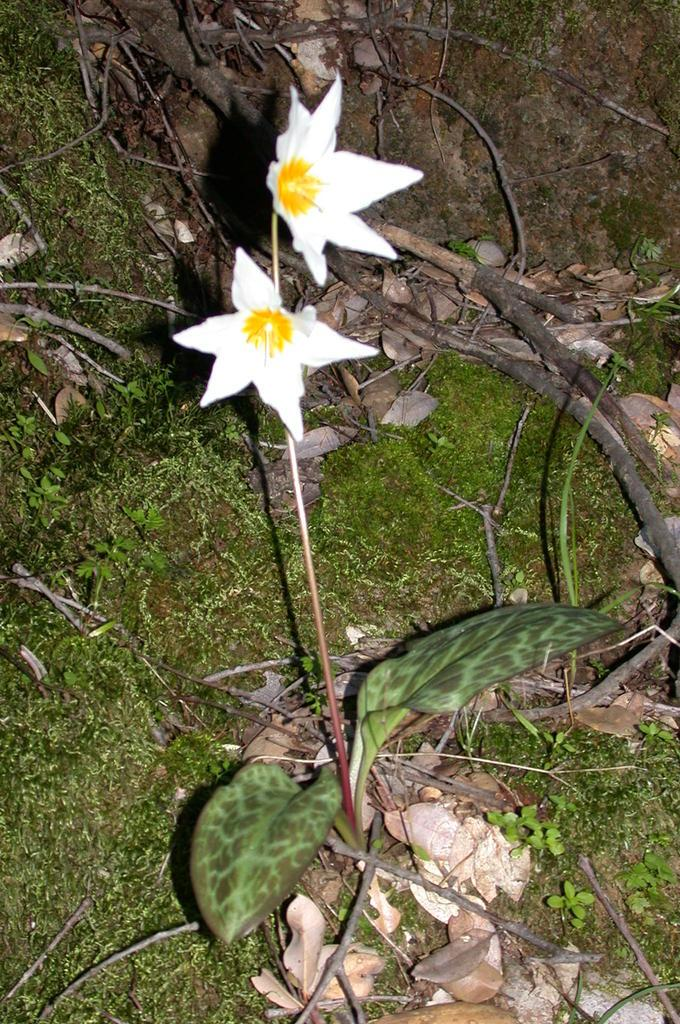What type of vegetation is present in the image? There is grass in the image. What other plant can be seen in the image? There is a plant in the image. What color are the flowers on the plant? The flowers on the plant are white-colored. What type of books can be found in the library depicted in the image? There is no library present in the image; it features grass, a plant, and white-colored flowers. 